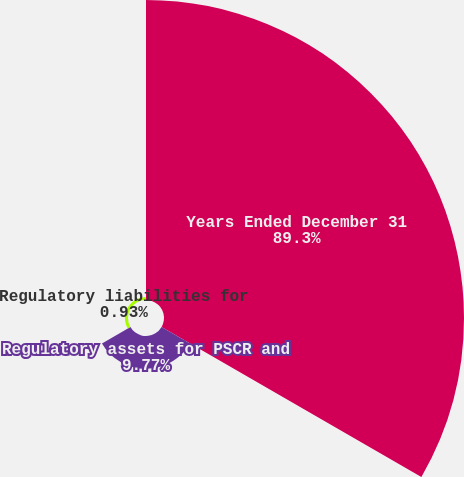<chart> <loc_0><loc_0><loc_500><loc_500><pie_chart><fcel>Years Ended December 31<fcel>Regulatory assets for PSCR and<fcel>Regulatory liabilities for<nl><fcel>89.3%<fcel>9.77%<fcel>0.93%<nl></chart> 